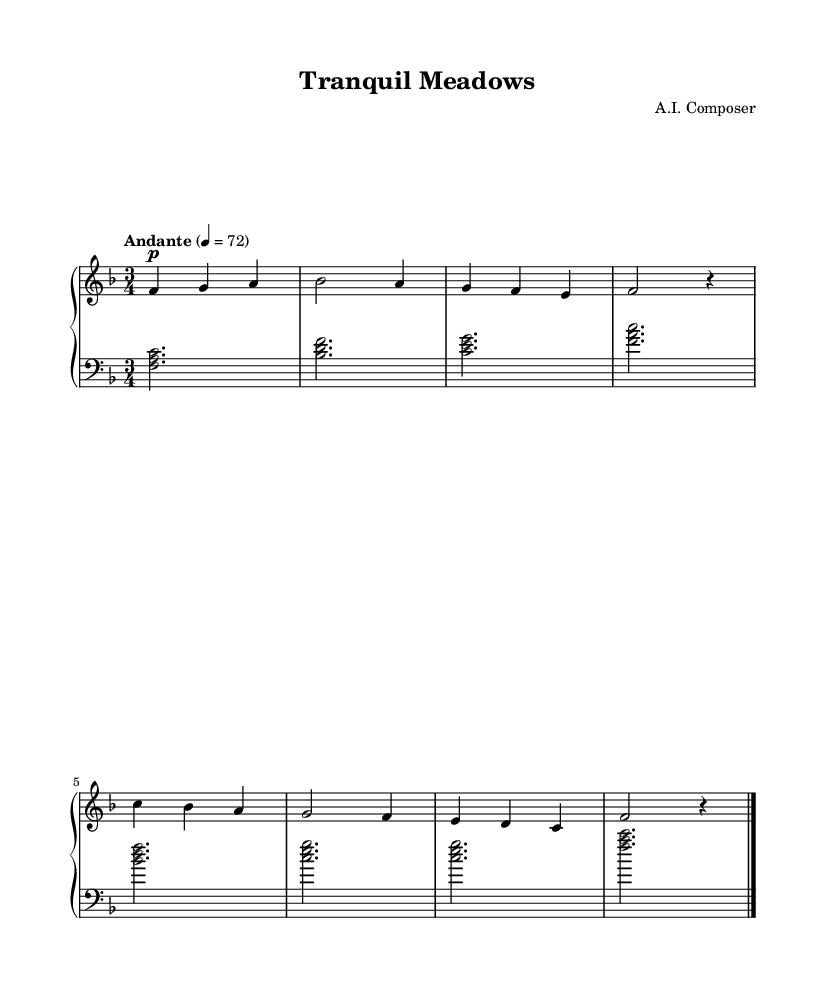What is the key signature of this music? The key signature is F major, which has one flat (B flat). This can be identified from the key signature notation at the beginning of the staff.
Answer: F major What is the time signature of this piece? The time signature is 3/4, indicated at the beginning of the music. This means there are three beats in each measure, and the quarter note gets one beat.
Answer: 3/4 What is the tempo marking given in the sheet music? The tempo marking is "Andante," indicating a moderate walking pace. This is typically indicated above the staff in musical notation.
Answer: Andante How many measures are played in this piece? The piece contains 8 measures, which can be counted by identifying the vertical bar lines dividing the music into sections.
Answer: 8 In what dynamics does the right hand start the piece? The right hand starts with the dynamic marking "p," which stands for piano, meaning softly. This is indicated at the beginning of the right-hand staff.
Answer: piano What are the first three notes played in the right hand? The first three notes played in the right hand are F, G, and A. This can be determined by looking at the notes in the first measure of the right-hand staff.
Answer: F, G, A What is the accompaniment pattern in the left hand? The left hand uses a pattern of broken chords throughout the piece, specifically using triadic chords that support the melody in the right hand. This can be recognized by the harmony formed by the bass notes.
Answer: Broken chords 